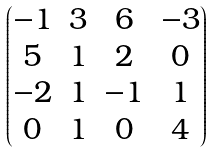<formula> <loc_0><loc_0><loc_500><loc_500>\begin{pmatrix} - 1 & 3 & 6 & - 3 \\ 5 & 1 & 2 & 0 \\ - 2 & 1 & - 1 & 1 \\ 0 & 1 & 0 & 4 \end{pmatrix}</formula> 